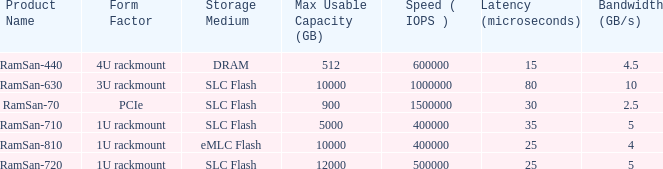Can you provide the total number of ramsan-720 hard drives? 1.0. 